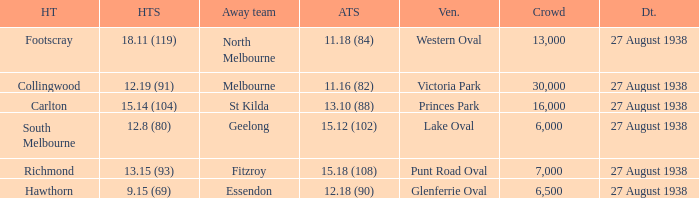Which away team scored 12.18 (90)? Essendon. 